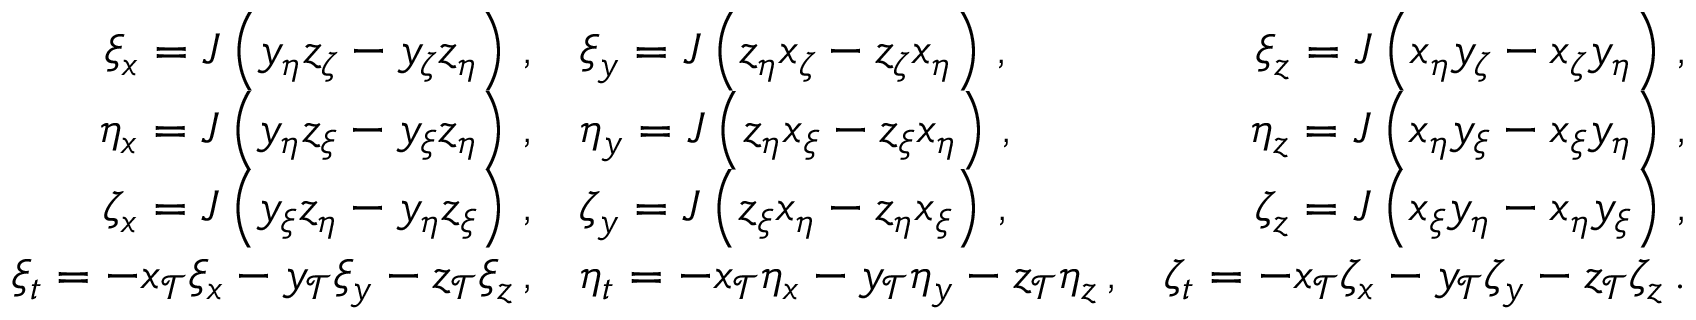Convert formula to latex. <formula><loc_0><loc_0><loc_500><loc_500>\begin{array} { r l r } { \xi _ { x } = J \left ( y _ { \eta } z _ { \zeta } - y _ { \zeta } z _ { \eta } \right ) \, , } & { \xi _ { y } = J \left ( z _ { \eta } x _ { \zeta } - z _ { \zeta } x _ { \eta } \right ) \, , } & { \xi _ { z } = J \left ( x _ { \eta } y _ { \zeta } - x _ { \zeta } y _ { \eta } \right ) \, , } \\ { \eta _ { x } = J \left ( y _ { \eta } z _ { \xi } - y _ { \xi } z _ { \eta } \right ) \, , } & { \eta _ { y } = J \left ( z _ { \eta } x _ { \xi } - z _ { \xi } x _ { \eta } \right ) \, , } & { \eta _ { z } = J \left ( x _ { \eta } y _ { \xi } - x _ { \xi } y _ { \eta } \right ) \, , } \\ { \zeta _ { x } = J \left ( y _ { \xi } z _ { \eta } - y _ { \eta } z _ { \xi } \right ) \, , } & { \zeta _ { y } = J \left ( z _ { \xi } x _ { \eta } - z _ { \eta } x _ { \xi } \right ) \, , } & { \zeta _ { z } = J \left ( x _ { \xi } y _ { \eta } - x _ { \eta } y _ { \xi } \right ) \, , } \\ { \xi _ { t } = - x _ { \mathcal { T } } \xi _ { x } - y _ { \mathcal { T } } \xi _ { y } - z _ { \mathcal { T } } \xi _ { z } \, , } & { \eta _ { t } = - x _ { \mathcal { T } } \eta _ { x } - y _ { \mathcal { T } } \eta _ { y } - z _ { \mathcal { T } } \eta _ { z } \, , } & { \zeta _ { t } = - x _ { \mathcal { T } } \zeta _ { x } - y _ { \mathcal { T } } \zeta _ { y } - z _ { \mathcal { T } } \zeta _ { z } \, . } \end{array}</formula> 